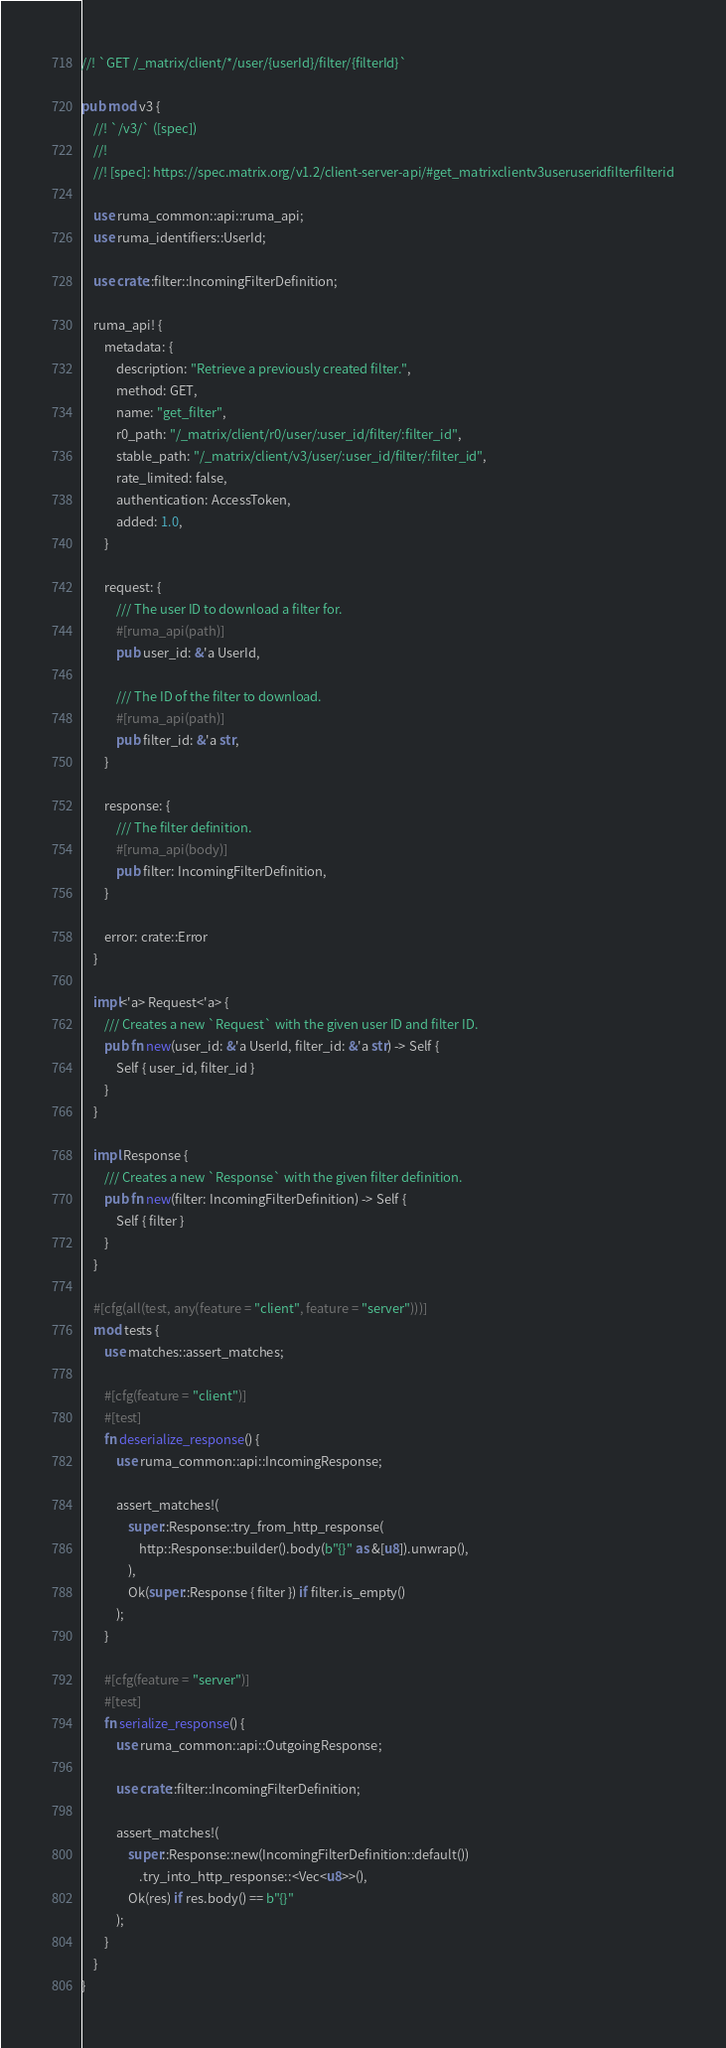<code> <loc_0><loc_0><loc_500><loc_500><_Rust_>//! `GET /_matrix/client/*/user/{userId}/filter/{filterId}`

pub mod v3 {
    //! `/v3/` ([spec])
    //!
    //! [spec]: https://spec.matrix.org/v1.2/client-server-api/#get_matrixclientv3useruseridfilterfilterid

    use ruma_common::api::ruma_api;
    use ruma_identifiers::UserId;

    use crate::filter::IncomingFilterDefinition;

    ruma_api! {
        metadata: {
            description: "Retrieve a previously created filter.",
            method: GET,
            name: "get_filter",
            r0_path: "/_matrix/client/r0/user/:user_id/filter/:filter_id",
            stable_path: "/_matrix/client/v3/user/:user_id/filter/:filter_id",
            rate_limited: false,
            authentication: AccessToken,
            added: 1.0,
        }

        request: {
            /// The user ID to download a filter for.
            #[ruma_api(path)]
            pub user_id: &'a UserId,

            /// The ID of the filter to download.
            #[ruma_api(path)]
            pub filter_id: &'a str,
        }

        response: {
            /// The filter definition.
            #[ruma_api(body)]
            pub filter: IncomingFilterDefinition,
        }

        error: crate::Error
    }

    impl<'a> Request<'a> {
        /// Creates a new `Request` with the given user ID and filter ID.
        pub fn new(user_id: &'a UserId, filter_id: &'a str) -> Self {
            Self { user_id, filter_id }
        }
    }

    impl Response {
        /// Creates a new `Response` with the given filter definition.
        pub fn new(filter: IncomingFilterDefinition) -> Self {
            Self { filter }
        }
    }

    #[cfg(all(test, any(feature = "client", feature = "server")))]
    mod tests {
        use matches::assert_matches;

        #[cfg(feature = "client")]
        #[test]
        fn deserialize_response() {
            use ruma_common::api::IncomingResponse;

            assert_matches!(
                super::Response::try_from_http_response(
                    http::Response::builder().body(b"{}" as &[u8]).unwrap(),
                ),
                Ok(super::Response { filter }) if filter.is_empty()
            );
        }

        #[cfg(feature = "server")]
        #[test]
        fn serialize_response() {
            use ruma_common::api::OutgoingResponse;

            use crate::filter::IncomingFilterDefinition;

            assert_matches!(
                super::Response::new(IncomingFilterDefinition::default())
                    .try_into_http_response::<Vec<u8>>(),
                Ok(res) if res.body() == b"{}"
            );
        }
    }
}
</code> 